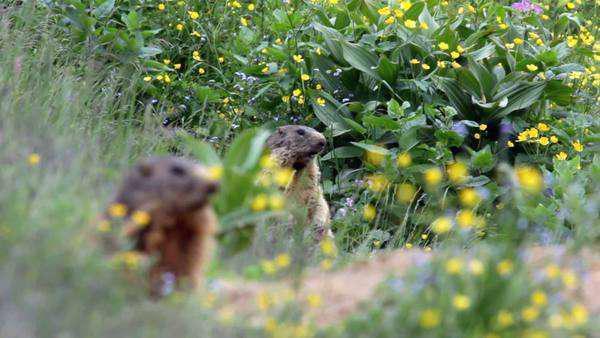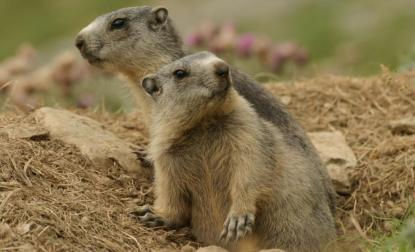The first image is the image on the left, the second image is the image on the right. Analyze the images presented: Is the assertion "A young boy is next to at least one groundhog." valid? Answer yes or no. No. The first image is the image on the left, the second image is the image on the right. Examine the images to the left and right. Is the description "In one image there is a boy next to at least one marmot." accurate? Answer yes or no. No. 